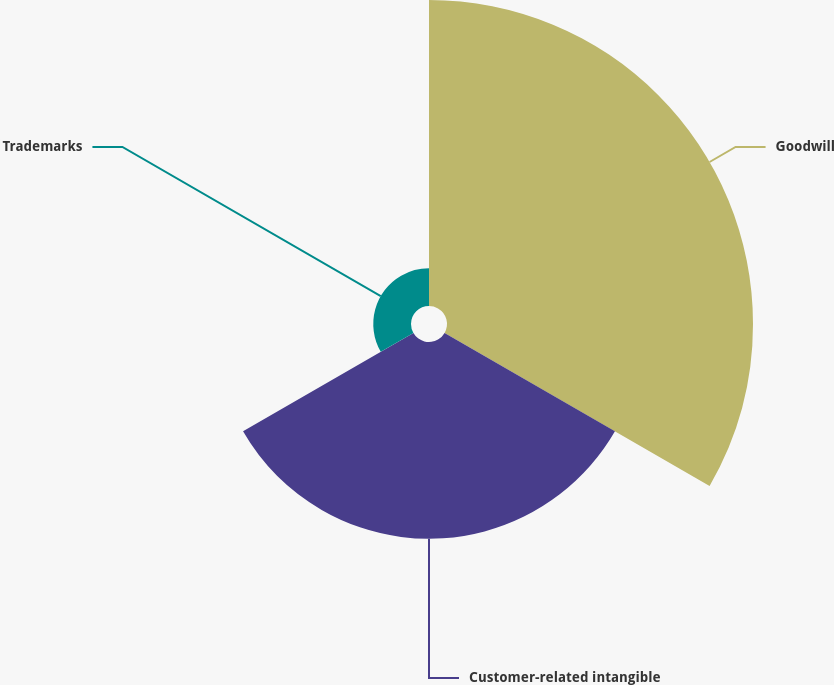Convert chart to OTSL. <chart><loc_0><loc_0><loc_500><loc_500><pie_chart><fcel>Goodwill<fcel>Customer-related intangible<fcel>Trademarks<nl><fcel>56.62%<fcel>36.4%<fcel>6.98%<nl></chart> 